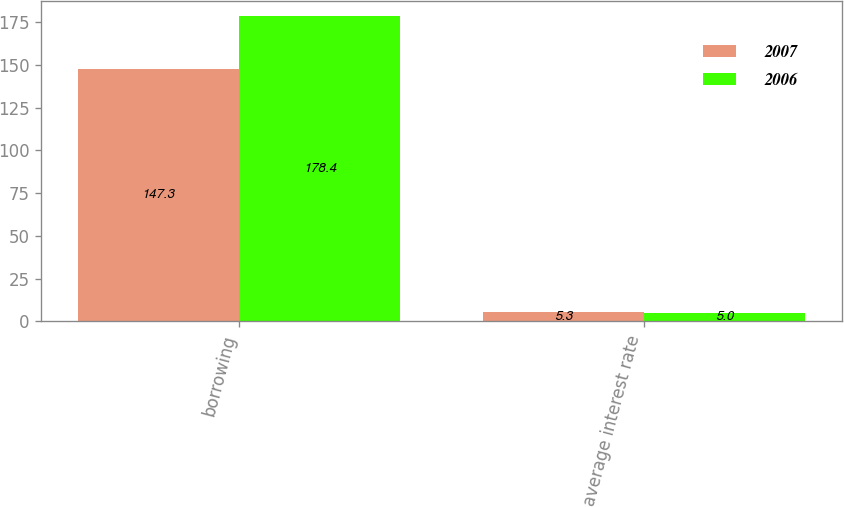Convert chart to OTSL. <chart><loc_0><loc_0><loc_500><loc_500><stacked_bar_chart><ecel><fcel>borrowing<fcel>average interest rate<nl><fcel>2007<fcel>147.3<fcel>5.3<nl><fcel>2006<fcel>178.4<fcel>5<nl></chart> 